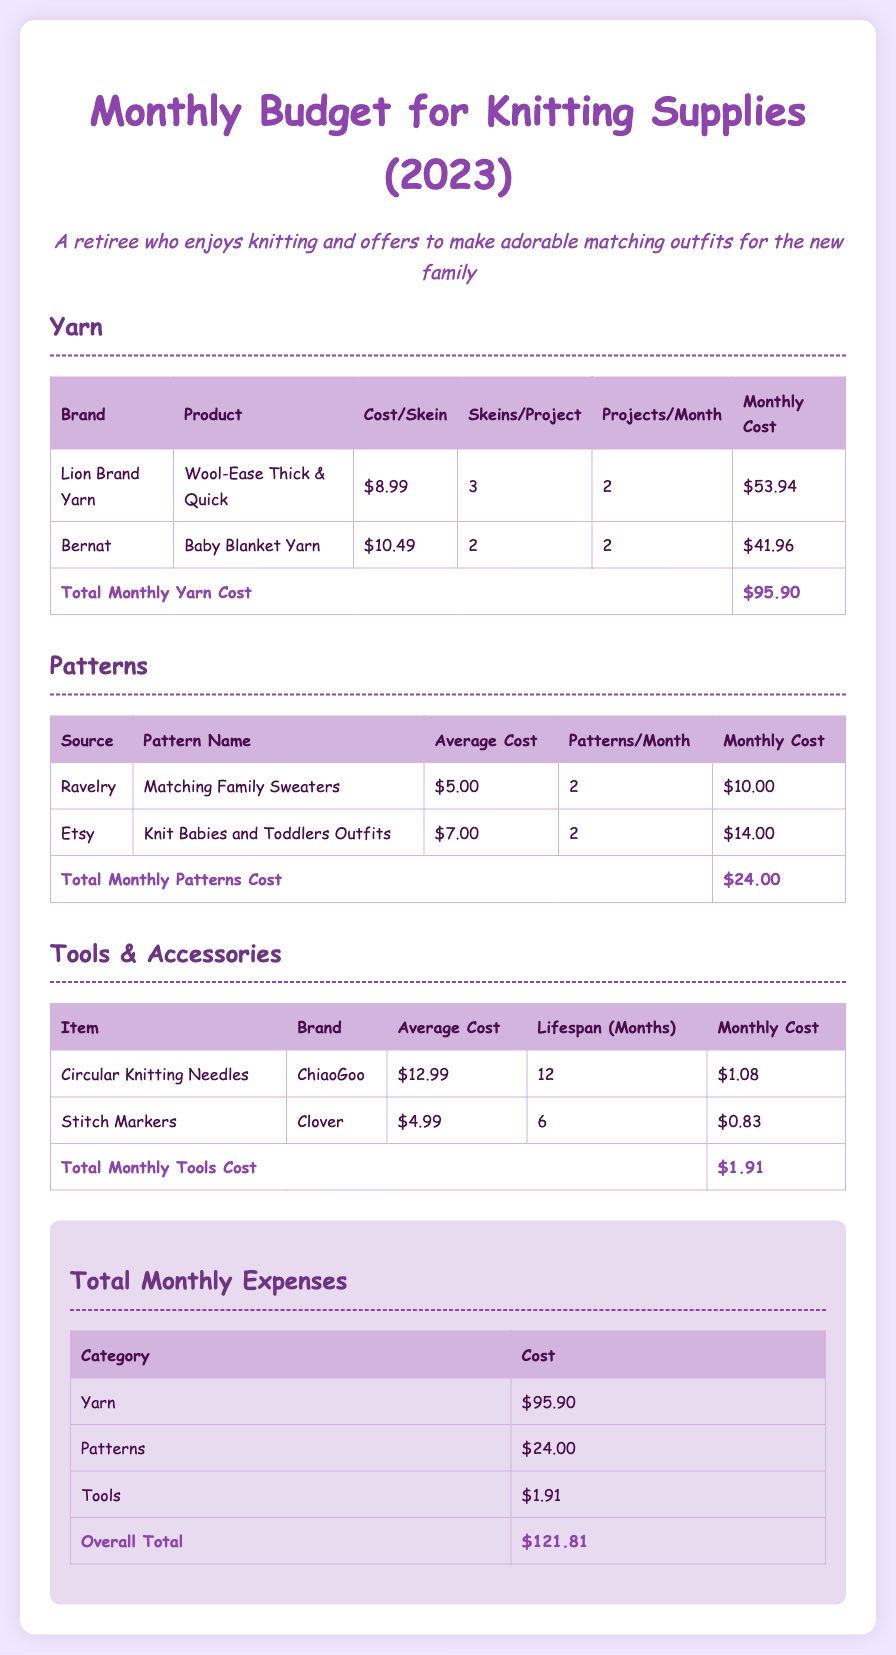What is the total monthly cost for yarn? The total monthly cost for yarn is calculated from the individual yarn costs, which is $95.90.
Answer: $95.90 How many projects per month are planned for Bernat Baby Blanket Yarn? The number of projects planned is indicated in the table, which shows 2 projects per month for Bernat Baby Blanket Yarn.
Answer: 2 What is the average cost of the Circular Knitting Needles? The average cost of the Circular Knitting Needles is specified in the tools table as $12.99.
Answer: $12.99 Which pattern costs the most on average? The document indicates the average costs of patterns, where the highest average cost is $7.00 for Knit Babies and Toddlers Outfits.
Answer: Knit Babies and Toddlers Outfits What is the total monthly cost for tools and accessories? The total monthly cost for tools and accessories is calculated in the document, which is $1.91.
Answer: $1.91 How many skeins are required per project for Wool-Ease Thick & Quick? The required skeins per project for Wool-Ease Thick & Quick is stated in the yarn table as 3 skeins.
Answer: 3 What is the overall total monthly budget for all knitting supplies? The overall total monthly budget combines costs from all categories, which is $121.81.
Answer: $121.81 How many patterns from Ravelry are included per month? The number of patterns from Ravelry included per month is indicated in the patterns table as 2 patterns.
Answer: 2 What is the lifespan of the Stitch Markers? The lifespan of the Stitch Markers is specified as 6 months in the tools table.
Answer: 6 